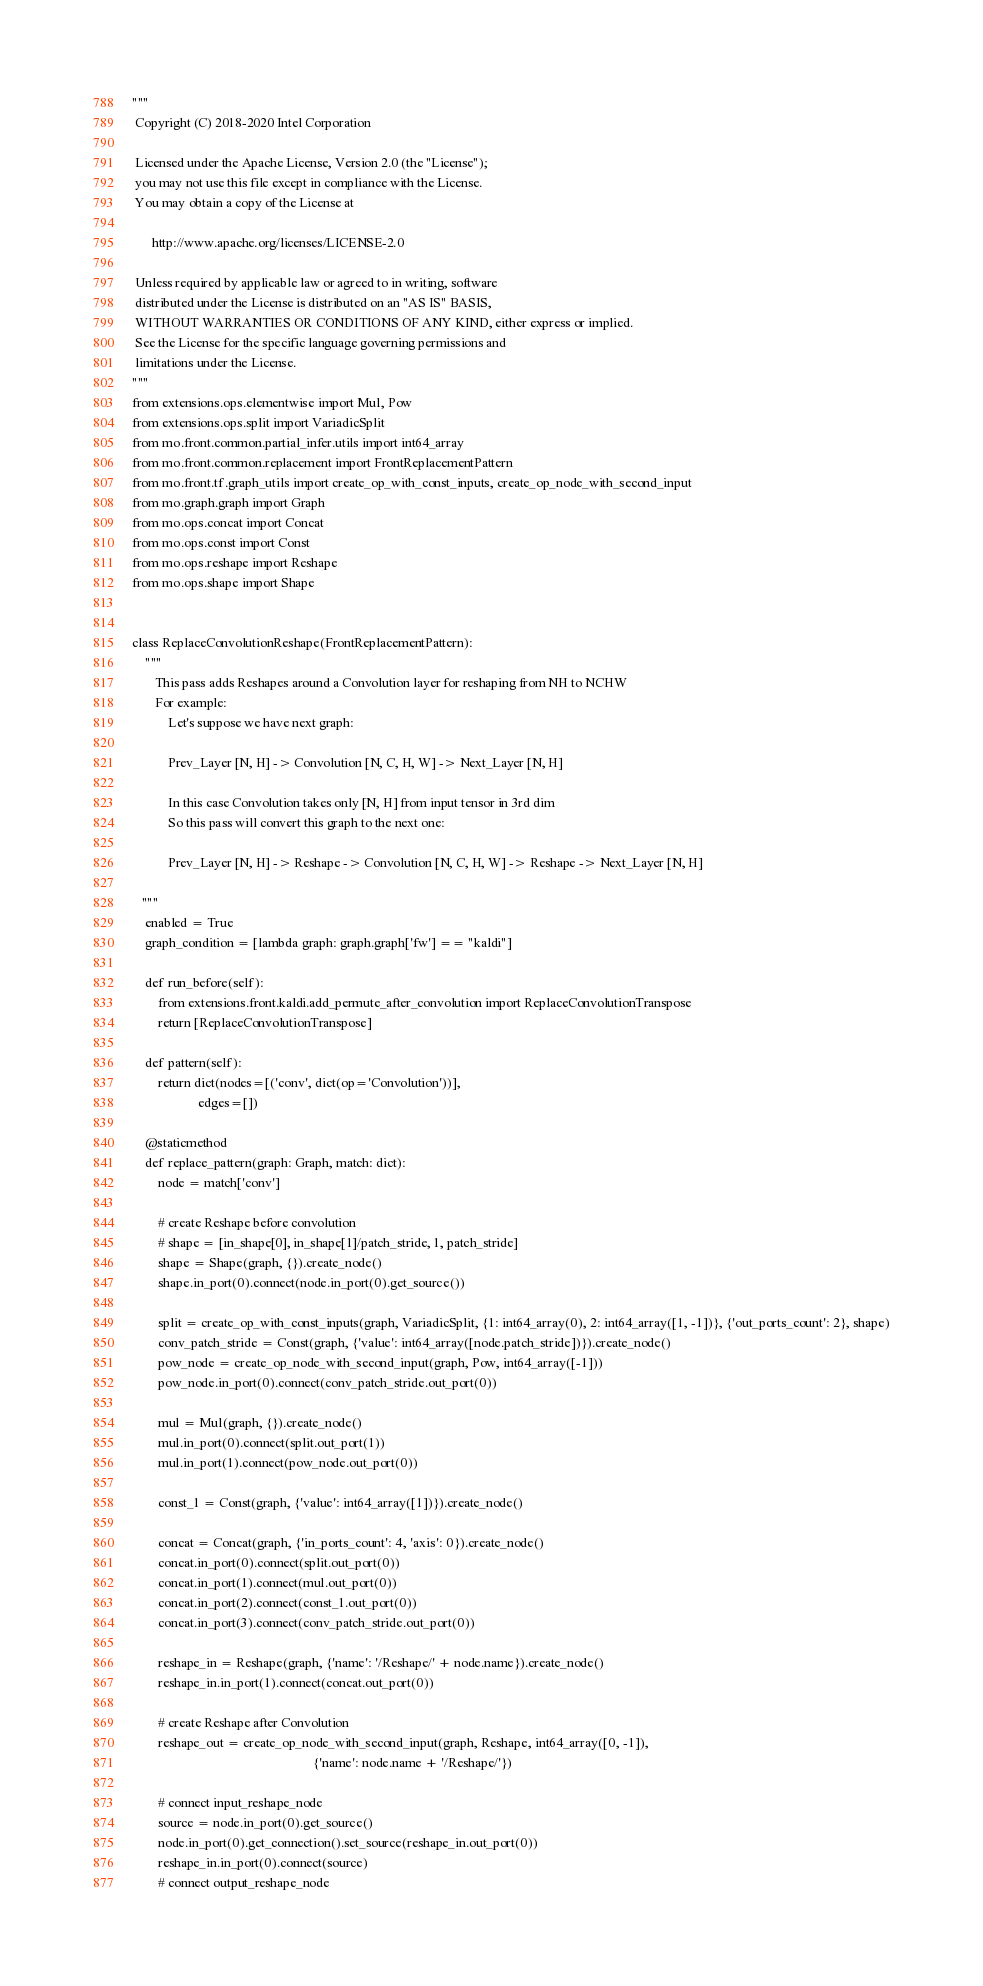<code> <loc_0><loc_0><loc_500><loc_500><_Python_>"""
 Copyright (C) 2018-2020 Intel Corporation

 Licensed under the Apache License, Version 2.0 (the "License");
 you may not use this file except in compliance with the License.
 You may obtain a copy of the License at

      http://www.apache.org/licenses/LICENSE-2.0

 Unless required by applicable law or agreed to in writing, software
 distributed under the License is distributed on an "AS IS" BASIS,
 WITHOUT WARRANTIES OR CONDITIONS OF ANY KIND, either express or implied.
 See the License for the specific language governing permissions and
 limitations under the License.
"""
from extensions.ops.elementwise import Mul, Pow
from extensions.ops.split import VariadicSplit
from mo.front.common.partial_infer.utils import int64_array
from mo.front.common.replacement import FrontReplacementPattern
from mo.front.tf.graph_utils import create_op_with_const_inputs, create_op_node_with_second_input
from mo.graph.graph import Graph
from mo.ops.concat import Concat
from mo.ops.const import Const
from mo.ops.reshape import Reshape
from mo.ops.shape import Shape


class ReplaceConvolutionReshape(FrontReplacementPattern):
    """
       This pass adds Reshapes around a Convolution layer for reshaping from NH to NCHW
       For example:
           Let's suppose we have next graph:

           Prev_Layer [N, H] -> Convolution [N, C, H, W] -> Next_Layer [N, H]

           In this case Convolution takes only [N, H] from input tensor in 3rd dim
           So this pass will convert this graph to the next one:

           Prev_Layer [N, H] -> Reshape -> Convolution [N, C, H, W] -> Reshape -> Next_Layer [N, H]

   """
    enabled = True
    graph_condition = [lambda graph: graph.graph['fw'] == "kaldi"]

    def run_before(self):
        from extensions.front.kaldi.add_permute_after_convolution import ReplaceConvolutionTranspose
        return [ReplaceConvolutionTranspose]

    def pattern(self):
        return dict(nodes=[('conv', dict(op='Convolution'))],
                    edges=[])

    @staticmethod
    def replace_pattern(graph: Graph, match: dict):
        node = match['conv']

        # create Reshape before convolution
        # shape = [in_shape[0], in_shape[1]/patch_stride, 1, patch_stride]
        shape = Shape(graph, {}).create_node()
        shape.in_port(0).connect(node.in_port(0).get_source())

        split = create_op_with_const_inputs(graph, VariadicSplit, {1: int64_array(0), 2: int64_array([1, -1])}, {'out_ports_count': 2}, shape)
        conv_patch_stride = Const(graph, {'value': int64_array([node.patch_stride])}).create_node()
        pow_node = create_op_node_with_second_input(graph, Pow, int64_array([-1]))
        pow_node.in_port(0).connect(conv_patch_stride.out_port(0))

        mul = Mul(graph, {}).create_node()
        mul.in_port(0).connect(split.out_port(1))
        mul.in_port(1).connect(pow_node.out_port(0))

        const_1 = Const(graph, {'value': int64_array([1])}).create_node()

        concat = Concat(graph, {'in_ports_count': 4, 'axis': 0}).create_node()
        concat.in_port(0).connect(split.out_port(0))
        concat.in_port(1).connect(mul.out_port(0))
        concat.in_port(2).connect(const_1.out_port(0))
        concat.in_port(3).connect(conv_patch_stride.out_port(0))

        reshape_in = Reshape(graph, {'name': '/Reshape/' + node.name}).create_node()
        reshape_in.in_port(1).connect(concat.out_port(0))

        # create Reshape after Convolution
        reshape_out = create_op_node_with_second_input(graph, Reshape, int64_array([0, -1]),
                                                       {'name': node.name + '/Reshape/'})

        # connect input_reshape_node
        source = node.in_port(0).get_source()
        node.in_port(0).get_connection().set_source(reshape_in.out_port(0))
        reshape_in.in_port(0).connect(source)
        # connect output_reshape_node</code> 